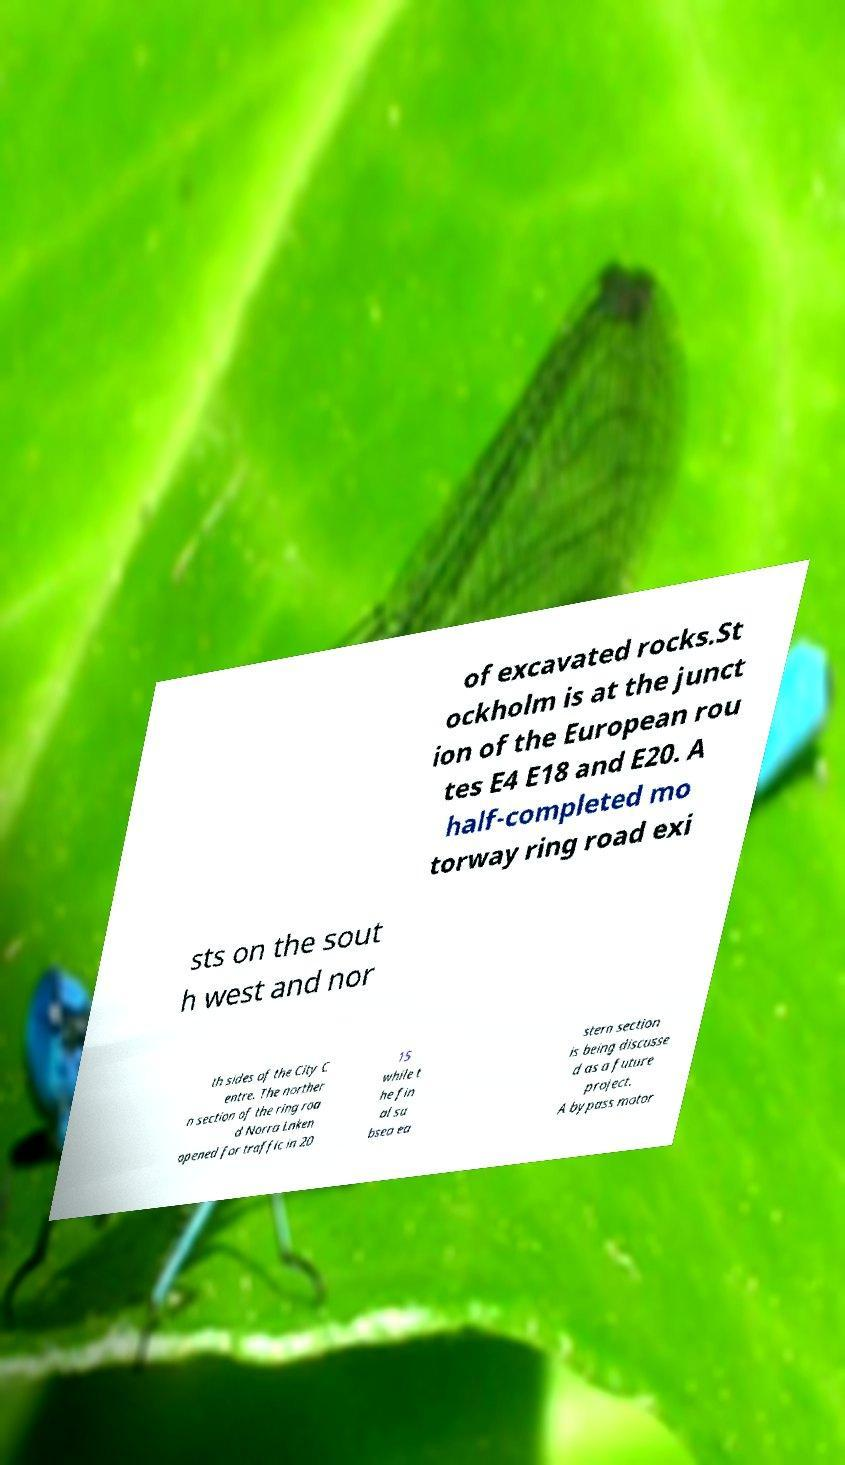Can you accurately transcribe the text from the provided image for me? of excavated rocks.St ockholm is at the junct ion of the European rou tes E4 E18 and E20. A half-completed mo torway ring road exi sts on the sout h west and nor th sides of the City C entre. The norther n section of the ring roa d Norra Lnken opened for traffic in 20 15 while t he fin al su bsea ea stern section is being discusse d as a future project. A bypass motor 